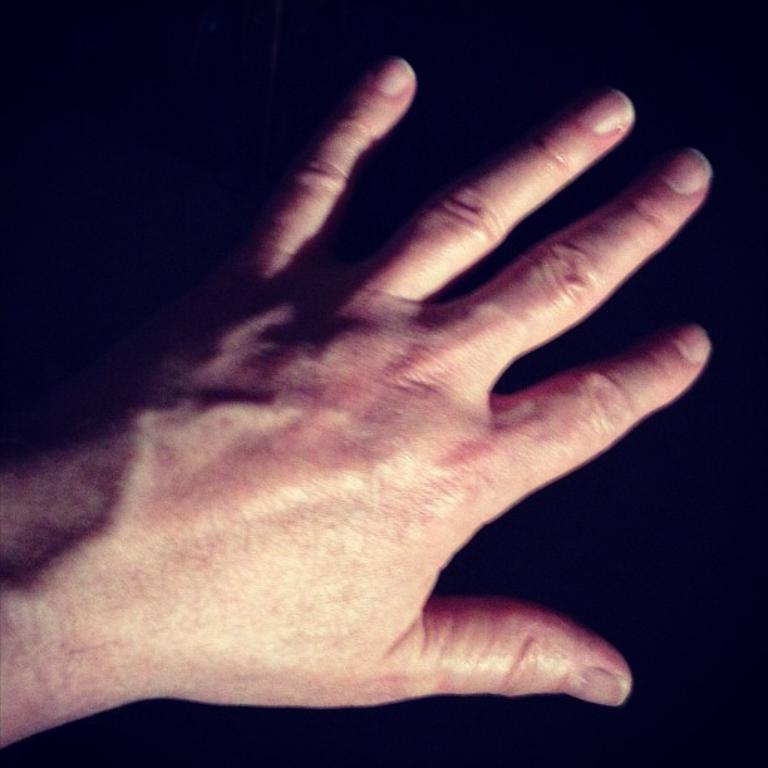What part of a person's body is visible in the image? There is a person's hand in the image. What can be inferred about the lighting conditions in the image? The background of the image is dark. What type of bread can be seen floating on the lake in the image? There is no lake or bread present in the image; it only features a person's hand and a dark background. 